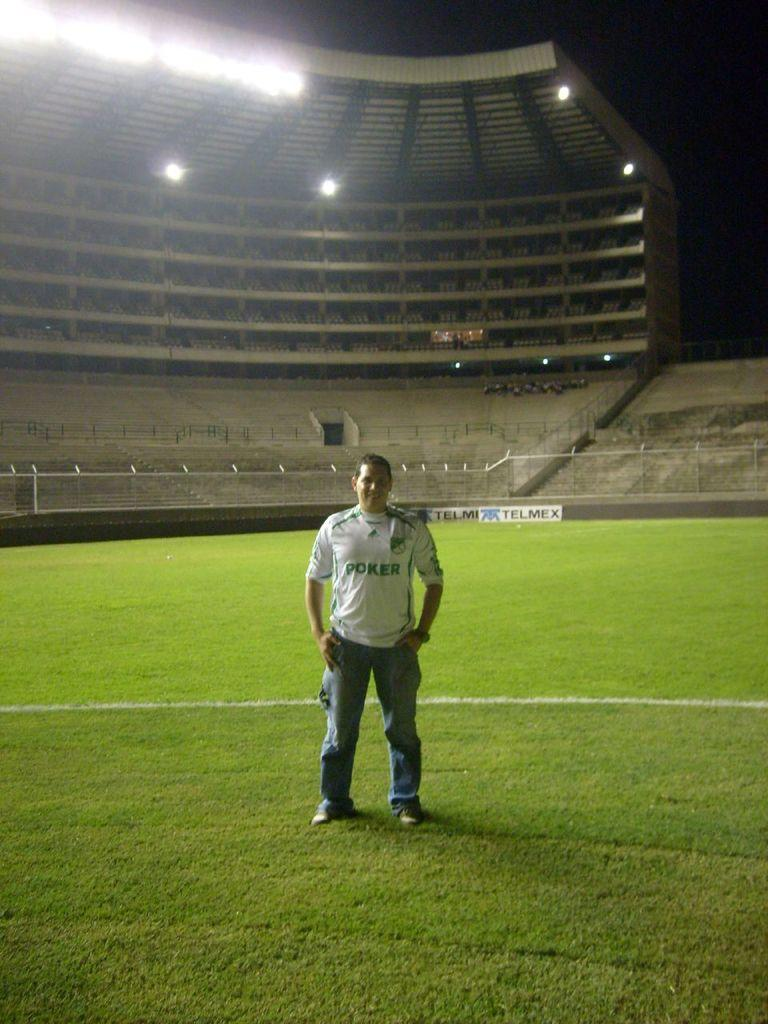<image>
Create a compact narrative representing the image presented. A man stands alone on a field wearing a jersey that says Poker on it. 